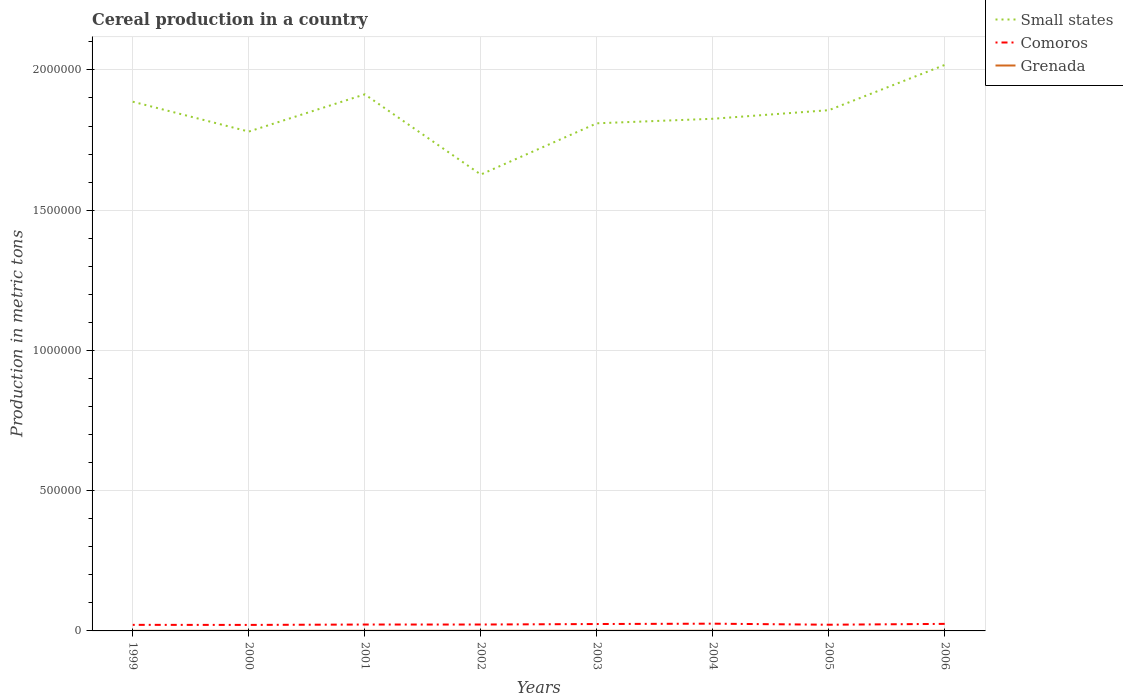How many different coloured lines are there?
Your response must be concise. 3. Is the number of lines equal to the number of legend labels?
Make the answer very short. Yes. Across all years, what is the maximum total cereal production in Grenada?
Offer a terse response. 300. What is the total total cereal production in Grenada in the graph?
Offer a terse response. -13. What is the difference between the highest and the second highest total cereal production in Comoros?
Ensure brevity in your answer.  4429. How many years are there in the graph?
Your answer should be very brief. 8. What is the difference between two consecutive major ticks on the Y-axis?
Your answer should be very brief. 5.00e+05. Are the values on the major ticks of Y-axis written in scientific E-notation?
Your answer should be compact. No. How are the legend labels stacked?
Your answer should be very brief. Vertical. What is the title of the graph?
Make the answer very short. Cereal production in a country. Does "Benin" appear as one of the legend labels in the graph?
Give a very brief answer. No. What is the label or title of the Y-axis?
Provide a succinct answer. Production in metric tons. What is the Production in metric tons in Small states in 1999?
Your response must be concise. 1.89e+06. What is the Production in metric tons of Comoros in 1999?
Provide a short and direct response. 2.16e+04. What is the Production in metric tons in Grenada in 1999?
Your answer should be very brief. 339. What is the Production in metric tons of Small states in 2000?
Ensure brevity in your answer.  1.78e+06. What is the Production in metric tons of Comoros in 2000?
Make the answer very short. 2.14e+04. What is the Production in metric tons in Grenada in 2000?
Your response must be concise. 375. What is the Production in metric tons of Small states in 2001?
Provide a succinct answer. 1.91e+06. What is the Production in metric tons in Comoros in 2001?
Make the answer very short. 2.28e+04. What is the Production in metric tons of Grenada in 2001?
Give a very brief answer. 388. What is the Production in metric tons in Small states in 2002?
Offer a terse response. 1.63e+06. What is the Production in metric tons in Comoros in 2002?
Offer a very short reply. 2.28e+04. What is the Production in metric tons of Grenada in 2002?
Offer a very short reply. 391. What is the Production in metric tons in Small states in 2003?
Offer a terse response. 1.81e+06. What is the Production in metric tons in Comoros in 2003?
Offer a terse response. 2.46e+04. What is the Production in metric tons in Grenada in 2003?
Offer a terse response. 441. What is the Production in metric tons in Small states in 2004?
Provide a succinct answer. 1.83e+06. What is the Production in metric tons of Comoros in 2004?
Your answer should be very brief. 2.58e+04. What is the Production in metric tons of Grenada in 2004?
Your answer should be compact. 477. What is the Production in metric tons in Small states in 2005?
Ensure brevity in your answer.  1.86e+06. What is the Production in metric tons in Comoros in 2005?
Offer a very short reply. 2.21e+04. What is the Production in metric tons of Grenada in 2005?
Give a very brief answer. 315. What is the Production in metric tons in Small states in 2006?
Provide a succinct answer. 2.02e+06. What is the Production in metric tons of Comoros in 2006?
Offer a very short reply. 2.51e+04. What is the Production in metric tons in Grenada in 2006?
Your response must be concise. 300. Across all years, what is the maximum Production in metric tons of Small states?
Provide a short and direct response. 2.02e+06. Across all years, what is the maximum Production in metric tons of Comoros?
Make the answer very short. 2.58e+04. Across all years, what is the maximum Production in metric tons in Grenada?
Give a very brief answer. 477. Across all years, what is the minimum Production in metric tons in Small states?
Provide a short and direct response. 1.63e+06. Across all years, what is the minimum Production in metric tons of Comoros?
Provide a short and direct response. 2.14e+04. Across all years, what is the minimum Production in metric tons in Grenada?
Your answer should be very brief. 300. What is the total Production in metric tons in Small states in the graph?
Ensure brevity in your answer.  1.47e+07. What is the total Production in metric tons in Comoros in the graph?
Your answer should be compact. 1.86e+05. What is the total Production in metric tons in Grenada in the graph?
Ensure brevity in your answer.  3026. What is the difference between the Production in metric tons in Small states in 1999 and that in 2000?
Provide a short and direct response. 1.07e+05. What is the difference between the Production in metric tons in Comoros in 1999 and that in 2000?
Your answer should be compact. 232. What is the difference between the Production in metric tons in Grenada in 1999 and that in 2000?
Your answer should be very brief. -36. What is the difference between the Production in metric tons of Small states in 1999 and that in 2001?
Your response must be concise. -2.62e+04. What is the difference between the Production in metric tons of Comoros in 1999 and that in 2001?
Ensure brevity in your answer.  -1134. What is the difference between the Production in metric tons of Grenada in 1999 and that in 2001?
Offer a very short reply. -49. What is the difference between the Production in metric tons of Small states in 1999 and that in 2002?
Provide a succinct answer. 2.60e+05. What is the difference between the Production in metric tons of Comoros in 1999 and that in 2002?
Provide a short and direct response. -1180. What is the difference between the Production in metric tons of Grenada in 1999 and that in 2002?
Give a very brief answer. -52. What is the difference between the Production in metric tons in Small states in 1999 and that in 2003?
Provide a short and direct response. 7.70e+04. What is the difference between the Production in metric tons of Comoros in 1999 and that in 2003?
Provide a short and direct response. -2952. What is the difference between the Production in metric tons in Grenada in 1999 and that in 2003?
Give a very brief answer. -102. What is the difference between the Production in metric tons of Small states in 1999 and that in 2004?
Provide a succinct answer. 6.09e+04. What is the difference between the Production in metric tons of Comoros in 1999 and that in 2004?
Provide a short and direct response. -4197. What is the difference between the Production in metric tons in Grenada in 1999 and that in 2004?
Provide a succinct answer. -138. What is the difference between the Production in metric tons of Small states in 1999 and that in 2005?
Provide a short and direct response. 3.02e+04. What is the difference between the Production in metric tons of Comoros in 1999 and that in 2005?
Your answer should be compact. -452. What is the difference between the Production in metric tons in Small states in 1999 and that in 2006?
Keep it short and to the point. -1.31e+05. What is the difference between the Production in metric tons of Comoros in 1999 and that in 2006?
Offer a very short reply. -3487. What is the difference between the Production in metric tons of Small states in 2000 and that in 2001?
Make the answer very short. -1.33e+05. What is the difference between the Production in metric tons in Comoros in 2000 and that in 2001?
Make the answer very short. -1366. What is the difference between the Production in metric tons of Small states in 2000 and that in 2002?
Provide a short and direct response. 1.53e+05. What is the difference between the Production in metric tons in Comoros in 2000 and that in 2002?
Make the answer very short. -1412. What is the difference between the Production in metric tons in Small states in 2000 and that in 2003?
Ensure brevity in your answer.  -2.95e+04. What is the difference between the Production in metric tons in Comoros in 2000 and that in 2003?
Provide a succinct answer. -3184. What is the difference between the Production in metric tons in Grenada in 2000 and that in 2003?
Provide a succinct answer. -66. What is the difference between the Production in metric tons of Small states in 2000 and that in 2004?
Make the answer very short. -4.57e+04. What is the difference between the Production in metric tons of Comoros in 2000 and that in 2004?
Ensure brevity in your answer.  -4429. What is the difference between the Production in metric tons in Grenada in 2000 and that in 2004?
Offer a terse response. -102. What is the difference between the Production in metric tons in Small states in 2000 and that in 2005?
Provide a short and direct response. -7.63e+04. What is the difference between the Production in metric tons in Comoros in 2000 and that in 2005?
Provide a short and direct response. -684. What is the difference between the Production in metric tons in Grenada in 2000 and that in 2005?
Ensure brevity in your answer.  60. What is the difference between the Production in metric tons in Small states in 2000 and that in 2006?
Your response must be concise. -2.38e+05. What is the difference between the Production in metric tons of Comoros in 2000 and that in 2006?
Your answer should be very brief. -3719. What is the difference between the Production in metric tons in Grenada in 2000 and that in 2006?
Your answer should be compact. 75. What is the difference between the Production in metric tons of Small states in 2001 and that in 2002?
Ensure brevity in your answer.  2.86e+05. What is the difference between the Production in metric tons of Comoros in 2001 and that in 2002?
Make the answer very short. -46. What is the difference between the Production in metric tons in Small states in 2001 and that in 2003?
Your response must be concise. 1.03e+05. What is the difference between the Production in metric tons of Comoros in 2001 and that in 2003?
Keep it short and to the point. -1818. What is the difference between the Production in metric tons of Grenada in 2001 and that in 2003?
Ensure brevity in your answer.  -53. What is the difference between the Production in metric tons of Small states in 2001 and that in 2004?
Provide a short and direct response. 8.71e+04. What is the difference between the Production in metric tons of Comoros in 2001 and that in 2004?
Keep it short and to the point. -3063. What is the difference between the Production in metric tons in Grenada in 2001 and that in 2004?
Your answer should be very brief. -89. What is the difference between the Production in metric tons of Small states in 2001 and that in 2005?
Offer a very short reply. 5.64e+04. What is the difference between the Production in metric tons of Comoros in 2001 and that in 2005?
Provide a short and direct response. 682. What is the difference between the Production in metric tons of Small states in 2001 and that in 2006?
Make the answer very short. -1.05e+05. What is the difference between the Production in metric tons of Comoros in 2001 and that in 2006?
Offer a terse response. -2353. What is the difference between the Production in metric tons of Small states in 2002 and that in 2003?
Your answer should be very brief. -1.83e+05. What is the difference between the Production in metric tons in Comoros in 2002 and that in 2003?
Your response must be concise. -1772. What is the difference between the Production in metric tons in Grenada in 2002 and that in 2003?
Offer a terse response. -50. What is the difference between the Production in metric tons of Small states in 2002 and that in 2004?
Provide a short and direct response. -1.99e+05. What is the difference between the Production in metric tons of Comoros in 2002 and that in 2004?
Your answer should be very brief. -3017. What is the difference between the Production in metric tons of Grenada in 2002 and that in 2004?
Offer a very short reply. -86. What is the difference between the Production in metric tons in Small states in 2002 and that in 2005?
Provide a succinct answer. -2.29e+05. What is the difference between the Production in metric tons of Comoros in 2002 and that in 2005?
Offer a very short reply. 728. What is the difference between the Production in metric tons in Grenada in 2002 and that in 2005?
Give a very brief answer. 76. What is the difference between the Production in metric tons of Small states in 2002 and that in 2006?
Keep it short and to the point. -3.91e+05. What is the difference between the Production in metric tons in Comoros in 2002 and that in 2006?
Provide a short and direct response. -2307. What is the difference between the Production in metric tons of Grenada in 2002 and that in 2006?
Your answer should be very brief. 91. What is the difference between the Production in metric tons of Small states in 2003 and that in 2004?
Offer a very short reply. -1.62e+04. What is the difference between the Production in metric tons of Comoros in 2003 and that in 2004?
Keep it short and to the point. -1245. What is the difference between the Production in metric tons in Grenada in 2003 and that in 2004?
Make the answer very short. -36. What is the difference between the Production in metric tons in Small states in 2003 and that in 2005?
Make the answer very short. -4.68e+04. What is the difference between the Production in metric tons of Comoros in 2003 and that in 2005?
Ensure brevity in your answer.  2500. What is the difference between the Production in metric tons in Grenada in 2003 and that in 2005?
Provide a short and direct response. 126. What is the difference between the Production in metric tons in Small states in 2003 and that in 2006?
Offer a terse response. -2.08e+05. What is the difference between the Production in metric tons of Comoros in 2003 and that in 2006?
Offer a very short reply. -535. What is the difference between the Production in metric tons of Grenada in 2003 and that in 2006?
Your response must be concise. 141. What is the difference between the Production in metric tons in Small states in 2004 and that in 2005?
Make the answer very short. -3.07e+04. What is the difference between the Production in metric tons in Comoros in 2004 and that in 2005?
Ensure brevity in your answer.  3745. What is the difference between the Production in metric tons in Grenada in 2004 and that in 2005?
Your response must be concise. 162. What is the difference between the Production in metric tons in Small states in 2004 and that in 2006?
Offer a terse response. -1.92e+05. What is the difference between the Production in metric tons of Comoros in 2004 and that in 2006?
Your answer should be compact. 710. What is the difference between the Production in metric tons of Grenada in 2004 and that in 2006?
Your answer should be very brief. 177. What is the difference between the Production in metric tons in Small states in 2005 and that in 2006?
Your answer should be compact. -1.61e+05. What is the difference between the Production in metric tons in Comoros in 2005 and that in 2006?
Ensure brevity in your answer.  -3035. What is the difference between the Production in metric tons in Grenada in 2005 and that in 2006?
Keep it short and to the point. 15. What is the difference between the Production in metric tons in Small states in 1999 and the Production in metric tons in Comoros in 2000?
Keep it short and to the point. 1.87e+06. What is the difference between the Production in metric tons in Small states in 1999 and the Production in metric tons in Grenada in 2000?
Your answer should be very brief. 1.89e+06. What is the difference between the Production in metric tons in Comoros in 1999 and the Production in metric tons in Grenada in 2000?
Keep it short and to the point. 2.13e+04. What is the difference between the Production in metric tons of Small states in 1999 and the Production in metric tons of Comoros in 2001?
Your answer should be very brief. 1.86e+06. What is the difference between the Production in metric tons in Small states in 1999 and the Production in metric tons in Grenada in 2001?
Your response must be concise. 1.89e+06. What is the difference between the Production in metric tons in Comoros in 1999 and the Production in metric tons in Grenada in 2001?
Your answer should be compact. 2.12e+04. What is the difference between the Production in metric tons in Small states in 1999 and the Production in metric tons in Comoros in 2002?
Make the answer very short. 1.86e+06. What is the difference between the Production in metric tons in Small states in 1999 and the Production in metric tons in Grenada in 2002?
Offer a very short reply. 1.89e+06. What is the difference between the Production in metric tons of Comoros in 1999 and the Production in metric tons of Grenada in 2002?
Your answer should be compact. 2.12e+04. What is the difference between the Production in metric tons of Small states in 1999 and the Production in metric tons of Comoros in 2003?
Keep it short and to the point. 1.86e+06. What is the difference between the Production in metric tons of Small states in 1999 and the Production in metric tons of Grenada in 2003?
Provide a succinct answer. 1.89e+06. What is the difference between the Production in metric tons in Comoros in 1999 and the Production in metric tons in Grenada in 2003?
Offer a very short reply. 2.12e+04. What is the difference between the Production in metric tons of Small states in 1999 and the Production in metric tons of Comoros in 2004?
Make the answer very short. 1.86e+06. What is the difference between the Production in metric tons of Small states in 1999 and the Production in metric tons of Grenada in 2004?
Your answer should be very brief. 1.89e+06. What is the difference between the Production in metric tons in Comoros in 1999 and the Production in metric tons in Grenada in 2004?
Ensure brevity in your answer.  2.12e+04. What is the difference between the Production in metric tons of Small states in 1999 and the Production in metric tons of Comoros in 2005?
Make the answer very short. 1.86e+06. What is the difference between the Production in metric tons in Small states in 1999 and the Production in metric tons in Grenada in 2005?
Your answer should be very brief. 1.89e+06. What is the difference between the Production in metric tons of Comoros in 1999 and the Production in metric tons of Grenada in 2005?
Your answer should be compact. 2.13e+04. What is the difference between the Production in metric tons in Small states in 1999 and the Production in metric tons in Comoros in 2006?
Provide a succinct answer. 1.86e+06. What is the difference between the Production in metric tons of Small states in 1999 and the Production in metric tons of Grenada in 2006?
Offer a very short reply. 1.89e+06. What is the difference between the Production in metric tons in Comoros in 1999 and the Production in metric tons in Grenada in 2006?
Your answer should be compact. 2.13e+04. What is the difference between the Production in metric tons of Small states in 2000 and the Production in metric tons of Comoros in 2001?
Keep it short and to the point. 1.76e+06. What is the difference between the Production in metric tons of Small states in 2000 and the Production in metric tons of Grenada in 2001?
Keep it short and to the point. 1.78e+06. What is the difference between the Production in metric tons in Comoros in 2000 and the Production in metric tons in Grenada in 2001?
Keep it short and to the point. 2.10e+04. What is the difference between the Production in metric tons of Small states in 2000 and the Production in metric tons of Comoros in 2002?
Offer a very short reply. 1.76e+06. What is the difference between the Production in metric tons in Small states in 2000 and the Production in metric tons in Grenada in 2002?
Make the answer very short. 1.78e+06. What is the difference between the Production in metric tons of Comoros in 2000 and the Production in metric tons of Grenada in 2002?
Provide a succinct answer. 2.10e+04. What is the difference between the Production in metric tons in Small states in 2000 and the Production in metric tons in Comoros in 2003?
Your response must be concise. 1.76e+06. What is the difference between the Production in metric tons in Small states in 2000 and the Production in metric tons in Grenada in 2003?
Provide a succinct answer. 1.78e+06. What is the difference between the Production in metric tons of Comoros in 2000 and the Production in metric tons of Grenada in 2003?
Offer a very short reply. 2.10e+04. What is the difference between the Production in metric tons of Small states in 2000 and the Production in metric tons of Comoros in 2004?
Your answer should be compact. 1.75e+06. What is the difference between the Production in metric tons in Small states in 2000 and the Production in metric tons in Grenada in 2004?
Ensure brevity in your answer.  1.78e+06. What is the difference between the Production in metric tons of Comoros in 2000 and the Production in metric tons of Grenada in 2004?
Keep it short and to the point. 2.09e+04. What is the difference between the Production in metric tons of Small states in 2000 and the Production in metric tons of Comoros in 2005?
Keep it short and to the point. 1.76e+06. What is the difference between the Production in metric tons in Small states in 2000 and the Production in metric tons in Grenada in 2005?
Offer a terse response. 1.78e+06. What is the difference between the Production in metric tons in Comoros in 2000 and the Production in metric tons in Grenada in 2005?
Make the answer very short. 2.11e+04. What is the difference between the Production in metric tons in Small states in 2000 and the Production in metric tons in Comoros in 2006?
Your answer should be compact. 1.76e+06. What is the difference between the Production in metric tons in Small states in 2000 and the Production in metric tons in Grenada in 2006?
Make the answer very short. 1.78e+06. What is the difference between the Production in metric tons in Comoros in 2000 and the Production in metric tons in Grenada in 2006?
Offer a very short reply. 2.11e+04. What is the difference between the Production in metric tons of Small states in 2001 and the Production in metric tons of Comoros in 2002?
Your answer should be compact. 1.89e+06. What is the difference between the Production in metric tons in Small states in 2001 and the Production in metric tons in Grenada in 2002?
Provide a succinct answer. 1.91e+06. What is the difference between the Production in metric tons in Comoros in 2001 and the Production in metric tons in Grenada in 2002?
Keep it short and to the point. 2.24e+04. What is the difference between the Production in metric tons of Small states in 2001 and the Production in metric tons of Comoros in 2003?
Give a very brief answer. 1.89e+06. What is the difference between the Production in metric tons of Small states in 2001 and the Production in metric tons of Grenada in 2003?
Ensure brevity in your answer.  1.91e+06. What is the difference between the Production in metric tons of Comoros in 2001 and the Production in metric tons of Grenada in 2003?
Make the answer very short. 2.23e+04. What is the difference between the Production in metric tons in Small states in 2001 and the Production in metric tons in Comoros in 2004?
Offer a very short reply. 1.89e+06. What is the difference between the Production in metric tons of Small states in 2001 and the Production in metric tons of Grenada in 2004?
Provide a short and direct response. 1.91e+06. What is the difference between the Production in metric tons of Comoros in 2001 and the Production in metric tons of Grenada in 2004?
Give a very brief answer. 2.23e+04. What is the difference between the Production in metric tons in Small states in 2001 and the Production in metric tons in Comoros in 2005?
Offer a terse response. 1.89e+06. What is the difference between the Production in metric tons in Small states in 2001 and the Production in metric tons in Grenada in 2005?
Provide a succinct answer. 1.91e+06. What is the difference between the Production in metric tons of Comoros in 2001 and the Production in metric tons of Grenada in 2005?
Give a very brief answer. 2.25e+04. What is the difference between the Production in metric tons of Small states in 2001 and the Production in metric tons of Comoros in 2006?
Keep it short and to the point. 1.89e+06. What is the difference between the Production in metric tons of Small states in 2001 and the Production in metric tons of Grenada in 2006?
Your answer should be compact. 1.91e+06. What is the difference between the Production in metric tons of Comoros in 2001 and the Production in metric tons of Grenada in 2006?
Your response must be concise. 2.25e+04. What is the difference between the Production in metric tons in Small states in 2002 and the Production in metric tons in Comoros in 2003?
Your response must be concise. 1.60e+06. What is the difference between the Production in metric tons in Small states in 2002 and the Production in metric tons in Grenada in 2003?
Your answer should be very brief. 1.63e+06. What is the difference between the Production in metric tons of Comoros in 2002 and the Production in metric tons of Grenada in 2003?
Provide a succinct answer. 2.24e+04. What is the difference between the Production in metric tons of Small states in 2002 and the Production in metric tons of Comoros in 2004?
Provide a succinct answer. 1.60e+06. What is the difference between the Production in metric tons in Small states in 2002 and the Production in metric tons in Grenada in 2004?
Ensure brevity in your answer.  1.63e+06. What is the difference between the Production in metric tons in Comoros in 2002 and the Production in metric tons in Grenada in 2004?
Your response must be concise. 2.23e+04. What is the difference between the Production in metric tons of Small states in 2002 and the Production in metric tons of Comoros in 2005?
Your answer should be compact. 1.61e+06. What is the difference between the Production in metric tons of Small states in 2002 and the Production in metric tons of Grenada in 2005?
Offer a very short reply. 1.63e+06. What is the difference between the Production in metric tons of Comoros in 2002 and the Production in metric tons of Grenada in 2005?
Your answer should be compact. 2.25e+04. What is the difference between the Production in metric tons of Small states in 2002 and the Production in metric tons of Comoros in 2006?
Provide a short and direct response. 1.60e+06. What is the difference between the Production in metric tons in Small states in 2002 and the Production in metric tons in Grenada in 2006?
Provide a short and direct response. 1.63e+06. What is the difference between the Production in metric tons in Comoros in 2002 and the Production in metric tons in Grenada in 2006?
Offer a terse response. 2.25e+04. What is the difference between the Production in metric tons of Small states in 2003 and the Production in metric tons of Comoros in 2004?
Give a very brief answer. 1.78e+06. What is the difference between the Production in metric tons in Small states in 2003 and the Production in metric tons in Grenada in 2004?
Your answer should be very brief. 1.81e+06. What is the difference between the Production in metric tons in Comoros in 2003 and the Production in metric tons in Grenada in 2004?
Your answer should be very brief. 2.41e+04. What is the difference between the Production in metric tons in Small states in 2003 and the Production in metric tons in Comoros in 2005?
Make the answer very short. 1.79e+06. What is the difference between the Production in metric tons in Small states in 2003 and the Production in metric tons in Grenada in 2005?
Ensure brevity in your answer.  1.81e+06. What is the difference between the Production in metric tons in Comoros in 2003 and the Production in metric tons in Grenada in 2005?
Your answer should be very brief. 2.43e+04. What is the difference between the Production in metric tons of Small states in 2003 and the Production in metric tons of Comoros in 2006?
Make the answer very short. 1.78e+06. What is the difference between the Production in metric tons of Small states in 2003 and the Production in metric tons of Grenada in 2006?
Your response must be concise. 1.81e+06. What is the difference between the Production in metric tons of Comoros in 2003 and the Production in metric tons of Grenada in 2006?
Offer a very short reply. 2.43e+04. What is the difference between the Production in metric tons in Small states in 2004 and the Production in metric tons in Comoros in 2005?
Provide a short and direct response. 1.80e+06. What is the difference between the Production in metric tons in Small states in 2004 and the Production in metric tons in Grenada in 2005?
Keep it short and to the point. 1.83e+06. What is the difference between the Production in metric tons of Comoros in 2004 and the Production in metric tons of Grenada in 2005?
Your response must be concise. 2.55e+04. What is the difference between the Production in metric tons in Small states in 2004 and the Production in metric tons in Comoros in 2006?
Your response must be concise. 1.80e+06. What is the difference between the Production in metric tons in Small states in 2004 and the Production in metric tons in Grenada in 2006?
Give a very brief answer. 1.83e+06. What is the difference between the Production in metric tons in Comoros in 2004 and the Production in metric tons in Grenada in 2006?
Offer a terse response. 2.55e+04. What is the difference between the Production in metric tons in Small states in 2005 and the Production in metric tons in Comoros in 2006?
Your response must be concise. 1.83e+06. What is the difference between the Production in metric tons of Small states in 2005 and the Production in metric tons of Grenada in 2006?
Provide a succinct answer. 1.86e+06. What is the difference between the Production in metric tons in Comoros in 2005 and the Production in metric tons in Grenada in 2006?
Your answer should be compact. 2.18e+04. What is the average Production in metric tons in Small states per year?
Offer a very short reply. 1.84e+06. What is the average Production in metric tons of Comoros per year?
Provide a short and direct response. 2.33e+04. What is the average Production in metric tons in Grenada per year?
Ensure brevity in your answer.  378.25. In the year 1999, what is the difference between the Production in metric tons in Small states and Production in metric tons in Comoros?
Offer a terse response. 1.87e+06. In the year 1999, what is the difference between the Production in metric tons of Small states and Production in metric tons of Grenada?
Provide a succinct answer. 1.89e+06. In the year 1999, what is the difference between the Production in metric tons in Comoros and Production in metric tons in Grenada?
Make the answer very short. 2.13e+04. In the year 2000, what is the difference between the Production in metric tons in Small states and Production in metric tons in Comoros?
Give a very brief answer. 1.76e+06. In the year 2000, what is the difference between the Production in metric tons of Small states and Production in metric tons of Grenada?
Make the answer very short. 1.78e+06. In the year 2000, what is the difference between the Production in metric tons in Comoros and Production in metric tons in Grenada?
Ensure brevity in your answer.  2.10e+04. In the year 2001, what is the difference between the Production in metric tons in Small states and Production in metric tons in Comoros?
Give a very brief answer. 1.89e+06. In the year 2001, what is the difference between the Production in metric tons of Small states and Production in metric tons of Grenada?
Your response must be concise. 1.91e+06. In the year 2001, what is the difference between the Production in metric tons of Comoros and Production in metric tons of Grenada?
Offer a very short reply. 2.24e+04. In the year 2002, what is the difference between the Production in metric tons of Small states and Production in metric tons of Comoros?
Make the answer very short. 1.60e+06. In the year 2002, what is the difference between the Production in metric tons in Small states and Production in metric tons in Grenada?
Your answer should be compact. 1.63e+06. In the year 2002, what is the difference between the Production in metric tons of Comoros and Production in metric tons of Grenada?
Give a very brief answer. 2.24e+04. In the year 2003, what is the difference between the Production in metric tons of Small states and Production in metric tons of Comoros?
Your answer should be compact. 1.79e+06. In the year 2003, what is the difference between the Production in metric tons of Small states and Production in metric tons of Grenada?
Offer a very short reply. 1.81e+06. In the year 2003, what is the difference between the Production in metric tons of Comoros and Production in metric tons of Grenada?
Offer a very short reply. 2.41e+04. In the year 2004, what is the difference between the Production in metric tons in Small states and Production in metric tons in Comoros?
Offer a very short reply. 1.80e+06. In the year 2004, what is the difference between the Production in metric tons in Small states and Production in metric tons in Grenada?
Your response must be concise. 1.83e+06. In the year 2004, what is the difference between the Production in metric tons of Comoros and Production in metric tons of Grenada?
Keep it short and to the point. 2.54e+04. In the year 2005, what is the difference between the Production in metric tons in Small states and Production in metric tons in Comoros?
Offer a very short reply. 1.83e+06. In the year 2005, what is the difference between the Production in metric tons in Small states and Production in metric tons in Grenada?
Provide a short and direct response. 1.86e+06. In the year 2005, what is the difference between the Production in metric tons in Comoros and Production in metric tons in Grenada?
Your answer should be compact. 2.18e+04. In the year 2006, what is the difference between the Production in metric tons of Small states and Production in metric tons of Comoros?
Your answer should be very brief. 1.99e+06. In the year 2006, what is the difference between the Production in metric tons in Small states and Production in metric tons in Grenada?
Ensure brevity in your answer.  2.02e+06. In the year 2006, what is the difference between the Production in metric tons of Comoros and Production in metric tons of Grenada?
Your answer should be very brief. 2.48e+04. What is the ratio of the Production in metric tons in Small states in 1999 to that in 2000?
Keep it short and to the point. 1.06. What is the ratio of the Production in metric tons of Comoros in 1999 to that in 2000?
Keep it short and to the point. 1.01. What is the ratio of the Production in metric tons of Grenada in 1999 to that in 2000?
Give a very brief answer. 0.9. What is the ratio of the Production in metric tons of Small states in 1999 to that in 2001?
Offer a very short reply. 0.99. What is the ratio of the Production in metric tons of Comoros in 1999 to that in 2001?
Provide a short and direct response. 0.95. What is the ratio of the Production in metric tons of Grenada in 1999 to that in 2001?
Ensure brevity in your answer.  0.87. What is the ratio of the Production in metric tons of Small states in 1999 to that in 2002?
Make the answer very short. 1.16. What is the ratio of the Production in metric tons of Comoros in 1999 to that in 2002?
Your answer should be compact. 0.95. What is the ratio of the Production in metric tons in Grenada in 1999 to that in 2002?
Make the answer very short. 0.87. What is the ratio of the Production in metric tons in Small states in 1999 to that in 2003?
Give a very brief answer. 1.04. What is the ratio of the Production in metric tons in Comoros in 1999 to that in 2003?
Your answer should be compact. 0.88. What is the ratio of the Production in metric tons of Grenada in 1999 to that in 2003?
Ensure brevity in your answer.  0.77. What is the ratio of the Production in metric tons in Small states in 1999 to that in 2004?
Provide a succinct answer. 1.03. What is the ratio of the Production in metric tons in Comoros in 1999 to that in 2004?
Make the answer very short. 0.84. What is the ratio of the Production in metric tons in Grenada in 1999 to that in 2004?
Give a very brief answer. 0.71. What is the ratio of the Production in metric tons in Small states in 1999 to that in 2005?
Your answer should be very brief. 1.02. What is the ratio of the Production in metric tons in Comoros in 1999 to that in 2005?
Offer a very short reply. 0.98. What is the ratio of the Production in metric tons in Grenada in 1999 to that in 2005?
Provide a short and direct response. 1.08. What is the ratio of the Production in metric tons in Small states in 1999 to that in 2006?
Your answer should be very brief. 0.93. What is the ratio of the Production in metric tons in Comoros in 1999 to that in 2006?
Your response must be concise. 0.86. What is the ratio of the Production in metric tons in Grenada in 1999 to that in 2006?
Make the answer very short. 1.13. What is the ratio of the Production in metric tons in Small states in 2000 to that in 2001?
Offer a terse response. 0.93. What is the ratio of the Production in metric tons in Comoros in 2000 to that in 2001?
Make the answer very short. 0.94. What is the ratio of the Production in metric tons in Grenada in 2000 to that in 2001?
Keep it short and to the point. 0.97. What is the ratio of the Production in metric tons of Small states in 2000 to that in 2002?
Provide a succinct answer. 1.09. What is the ratio of the Production in metric tons in Comoros in 2000 to that in 2002?
Offer a terse response. 0.94. What is the ratio of the Production in metric tons in Grenada in 2000 to that in 2002?
Your answer should be compact. 0.96. What is the ratio of the Production in metric tons of Small states in 2000 to that in 2003?
Your response must be concise. 0.98. What is the ratio of the Production in metric tons in Comoros in 2000 to that in 2003?
Offer a terse response. 0.87. What is the ratio of the Production in metric tons of Grenada in 2000 to that in 2003?
Your response must be concise. 0.85. What is the ratio of the Production in metric tons in Comoros in 2000 to that in 2004?
Offer a terse response. 0.83. What is the ratio of the Production in metric tons of Grenada in 2000 to that in 2004?
Provide a succinct answer. 0.79. What is the ratio of the Production in metric tons of Small states in 2000 to that in 2005?
Your answer should be very brief. 0.96. What is the ratio of the Production in metric tons of Grenada in 2000 to that in 2005?
Provide a short and direct response. 1.19. What is the ratio of the Production in metric tons of Small states in 2000 to that in 2006?
Offer a terse response. 0.88. What is the ratio of the Production in metric tons of Comoros in 2000 to that in 2006?
Offer a terse response. 0.85. What is the ratio of the Production in metric tons in Grenada in 2000 to that in 2006?
Provide a short and direct response. 1.25. What is the ratio of the Production in metric tons of Small states in 2001 to that in 2002?
Ensure brevity in your answer.  1.18. What is the ratio of the Production in metric tons of Comoros in 2001 to that in 2002?
Offer a terse response. 1. What is the ratio of the Production in metric tons of Grenada in 2001 to that in 2002?
Offer a very short reply. 0.99. What is the ratio of the Production in metric tons in Small states in 2001 to that in 2003?
Ensure brevity in your answer.  1.06. What is the ratio of the Production in metric tons in Comoros in 2001 to that in 2003?
Make the answer very short. 0.93. What is the ratio of the Production in metric tons in Grenada in 2001 to that in 2003?
Your response must be concise. 0.88. What is the ratio of the Production in metric tons of Small states in 2001 to that in 2004?
Provide a short and direct response. 1.05. What is the ratio of the Production in metric tons of Comoros in 2001 to that in 2004?
Your answer should be very brief. 0.88. What is the ratio of the Production in metric tons in Grenada in 2001 to that in 2004?
Give a very brief answer. 0.81. What is the ratio of the Production in metric tons of Small states in 2001 to that in 2005?
Your answer should be very brief. 1.03. What is the ratio of the Production in metric tons in Comoros in 2001 to that in 2005?
Make the answer very short. 1.03. What is the ratio of the Production in metric tons of Grenada in 2001 to that in 2005?
Provide a short and direct response. 1.23. What is the ratio of the Production in metric tons in Small states in 2001 to that in 2006?
Ensure brevity in your answer.  0.95. What is the ratio of the Production in metric tons of Comoros in 2001 to that in 2006?
Your answer should be compact. 0.91. What is the ratio of the Production in metric tons of Grenada in 2001 to that in 2006?
Provide a short and direct response. 1.29. What is the ratio of the Production in metric tons of Small states in 2002 to that in 2003?
Your answer should be very brief. 0.9. What is the ratio of the Production in metric tons in Comoros in 2002 to that in 2003?
Keep it short and to the point. 0.93. What is the ratio of the Production in metric tons in Grenada in 2002 to that in 2003?
Provide a short and direct response. 0.89. What is the ratio of the Production in metric tons of Small states in 2002 to that in 2004?
Ensure brevity in your answer.  0.89. What is the ratio of the Production in metric tons of Comoros in 2002 to that in 2004?
Make the answer very short. 0.88. What is the ratio of the Production in metric tons of Grenada in 2002 to that in 2004?
Provide a succinct answer. 0.82. What is the ratio of the Production in metric tons in Small states in 2002 to that in 2005?
Give a very brief answer. 0.88. What is the ratio of the Production in metric tons in Comoros in 2002 to that in 2005?
Your response must be concise. 1.03. What is the ratio of the Production in metric tons of Grenada in 2002 to that in 2005?
Provide a short and direct response. 1.24. What is the ratio of the Production in metric tons in Small states in 2002 to that in 2006?
Give a very brief answer. 0.81. What is the ratio of the Production in metric tons of Comoros in 2002 to that in 2006?
Your answer should be very brief. 0.91. What is the ratio of the Production in metric tons of Grenada in 2002 to that in 2006?
Offer a very short reply. 1.3. What is the ratio of the Production in metric tons in Comoros in 2003 to that in 2004?
Offer a very short reply. 0.95. What is the ratio of the Production in metric tons in Grenada in 2003 to that in 2004?
Your response must be concise. 0.92. What is the ratio of the Production in metric tons of Small states in 2003 to that in 2005?
Make the answer very short. 0.97. What is the ratio of the Production in metric tons in Comoros in 2003 to that in 2005?
Offer a terse response. 1.11. What is the ratio of the Production in metric tons of Small states in 2003 to that in 2006?
Keep it short and to the point. 0.9. What is the ratio of the Production in metric tons in Comoros in 2003 to that in 2006?
Provide a short and direct response. 0.98. What is the ratio of the Production in metric tons in Grenada in 2003 to that in 2006?
Your answer should be compact. 1.47. What is the ratio of the Production in metric tons of Small states in 2004 to that in 2005?
Keep it short and to the point. 0.98. What is the ratio of the Production in metric tons in Comoros in 2004 to that in 2005?
Make the answer very short. 1.17. What is the ratio of the Production in metric tons in Grenada in 2004 to that in 2005?
Your answer should be very brief. 1.51. What is the ratio of the Production in metric tons of Small states in 2004 to that in 2006?
Your answer should be very brief. 0.9. What is the ratio of the Production in metric tons in Comoros in 2004 to that in 2006?
Your answer should be compact. 1.03. What is the ratio of the Production in metric tons of Grenada in 2004 to that in 2006?
Your answer should be very brief. 1.59. What is the ratio of the Production in metric tons in Comoros in 2005 to that in 2006?
Offer a terse response. 0.88. What is the difference between the highest and the second highest Production in metric tons of Small states?
Give a very brief answer. 1.05e+05. What is the difference between the highest and the second highest Production in metric tons of Comoros?
Offer a very short reply. 710. What is the difference between the highest and the lowest Production in metric tons of Small states?
Ensure brevity in your answer.  3.91e+05. What is the difference between the highest and the lowest Production in metric tons in Comoros?
Your answer should be very brief. 4429. What is the difference between the highest and the lowest Production in metric tons in Grenada?
Your answer should be very brief. 177. 